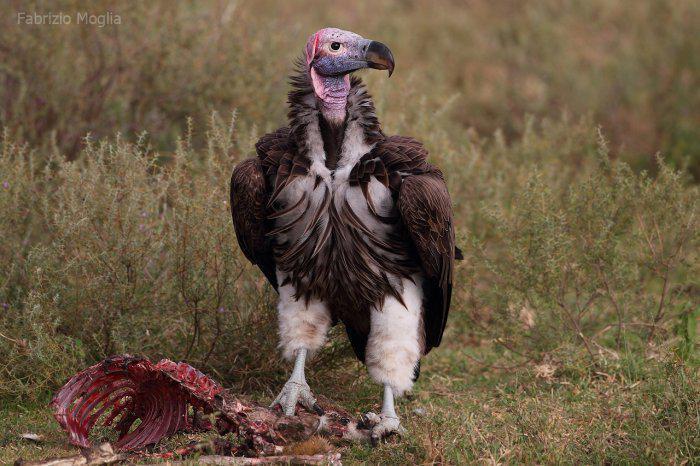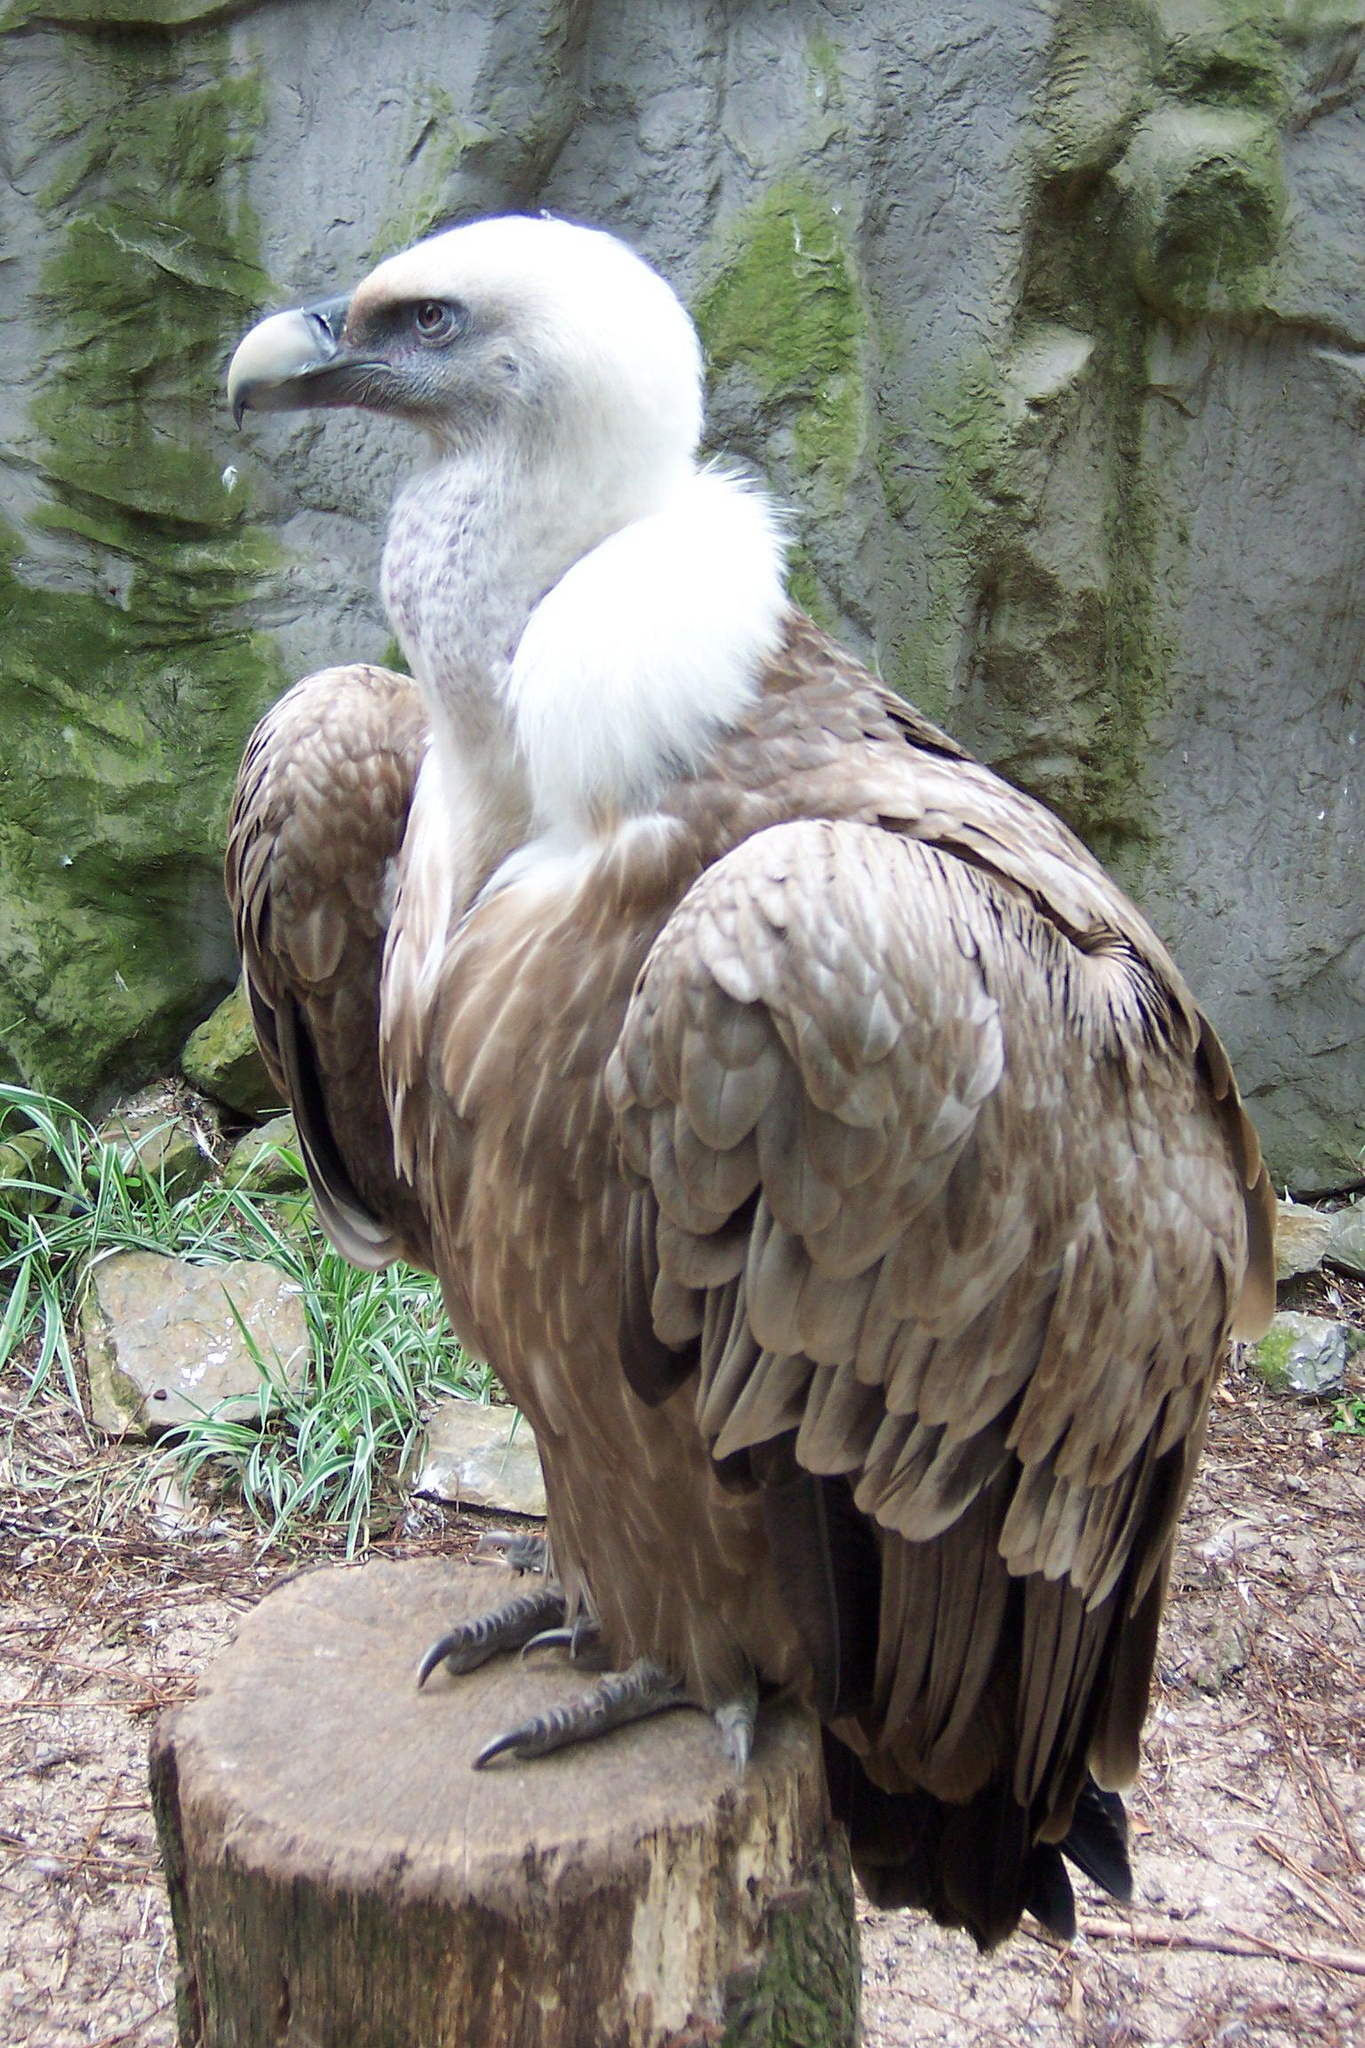The first image is the image on the left, the second image is the image on the right. Considering the images on both sides, is "There are two vultures in the image pair" valid? Answer yes or no. Yes. 